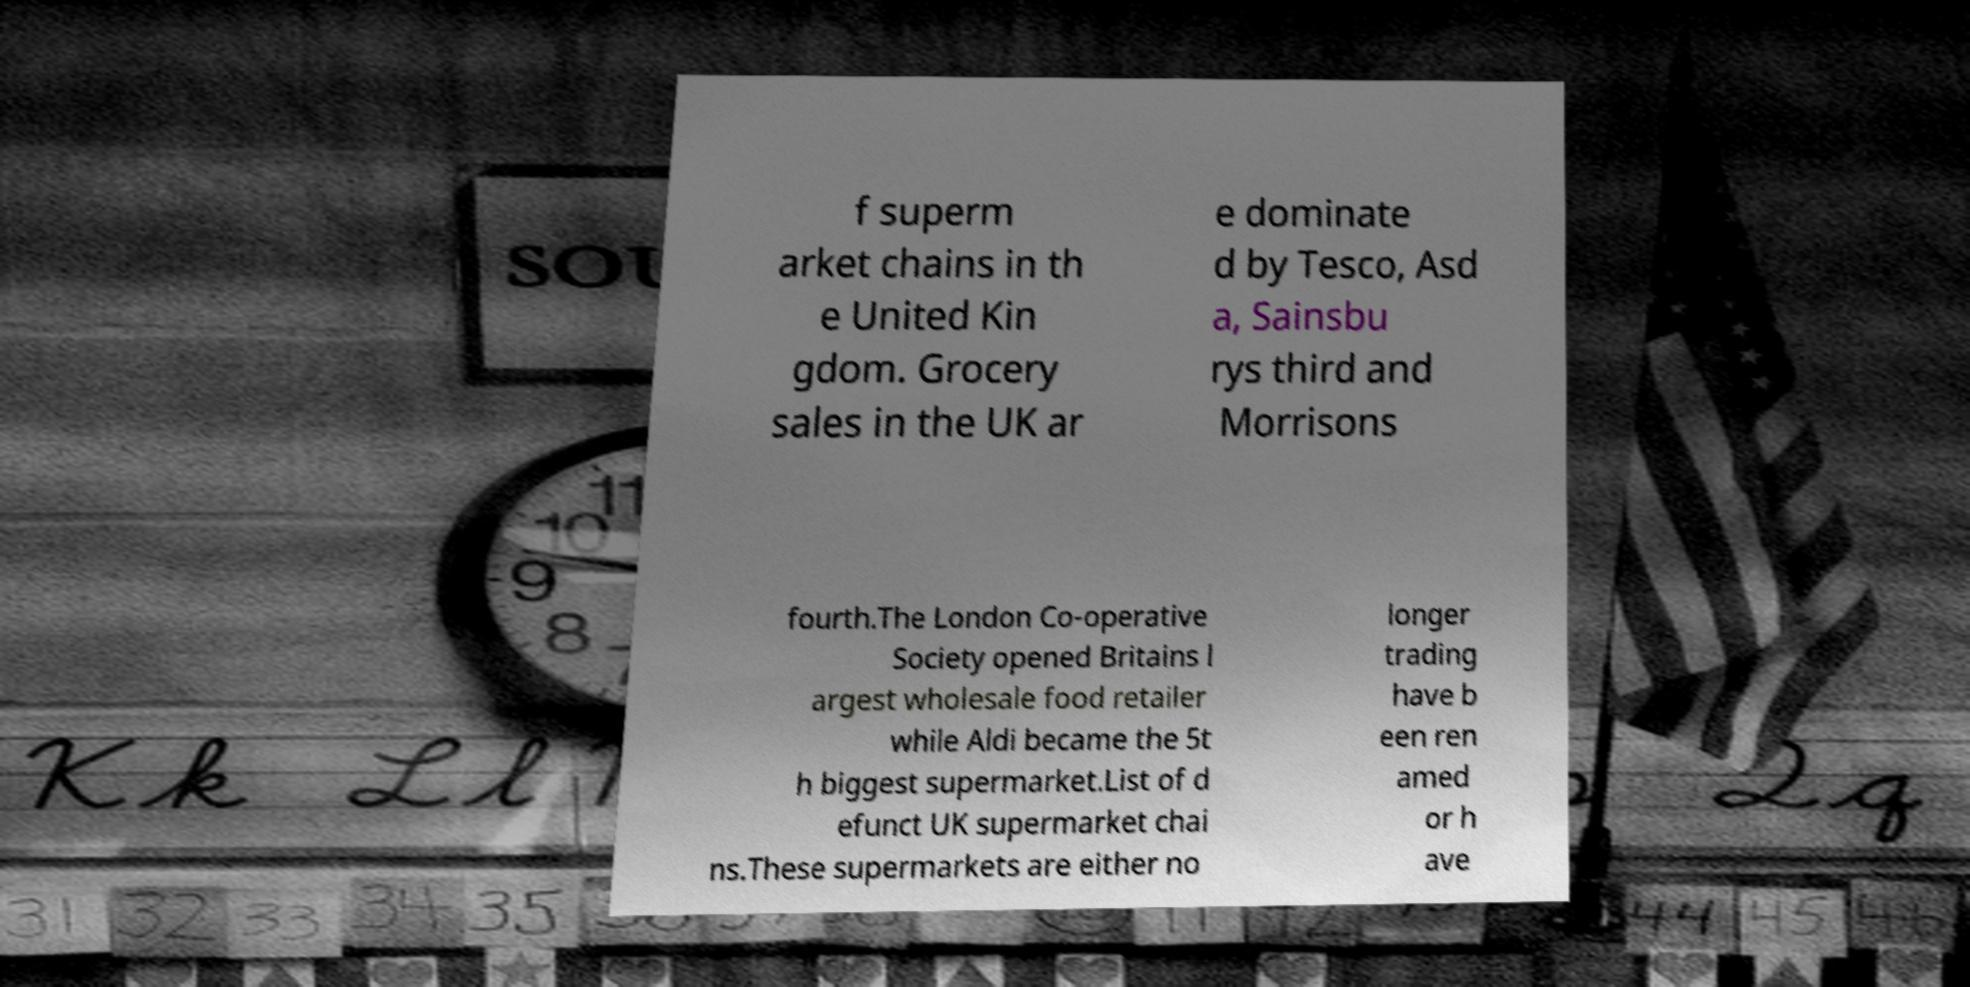There's text embedded in this image that I need extracted. Can you transcribe it verbatim? f superm arket chains in th e United Kin gdom. Grocery sales in the UK ar e dominate d by Tesco, Asd a, Sainsbu rys third and Morrisons fourth.The London Co-operative Society opened Britains l argest wholesale food retailer while Aldi became the 5t h biggest supermarket.List of d efunct UK supermarket chai ns.These supermarkets are either no longer trading have b een ren amed or h ave 